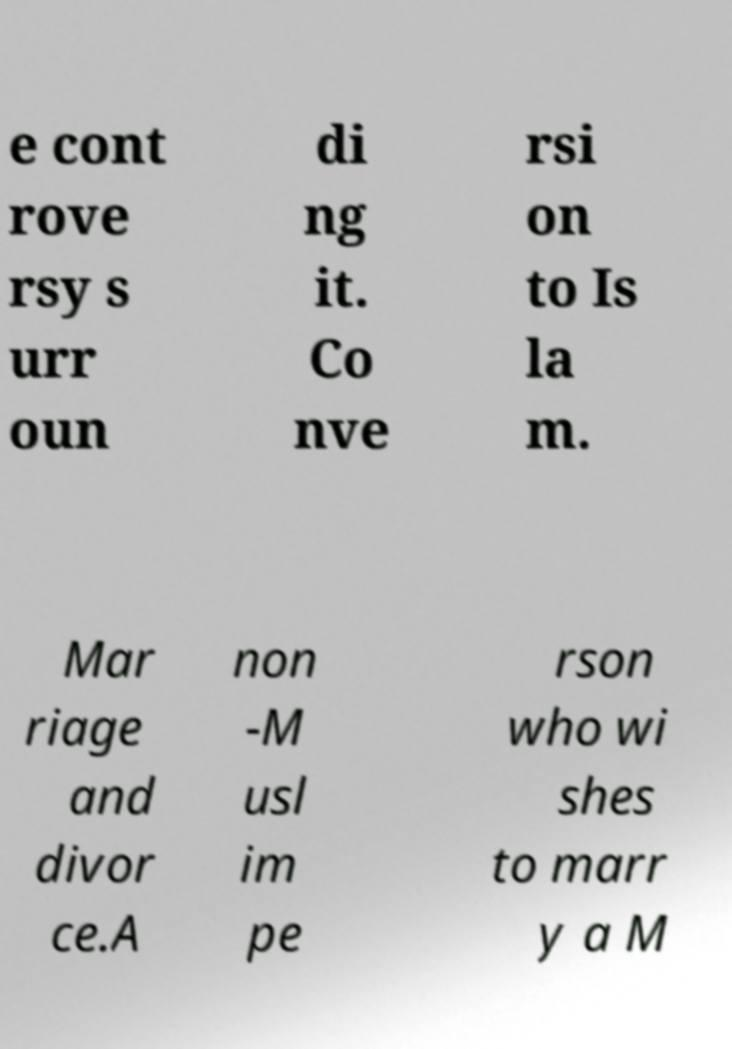Please read and relay the text visible in this image. What does it say? e cont rove rsy s urr oun di ng it. Co nve rsi on to Is la m. Mar riage and divor ce.A non -M usl im pe rson who wi shes to marr y a M 